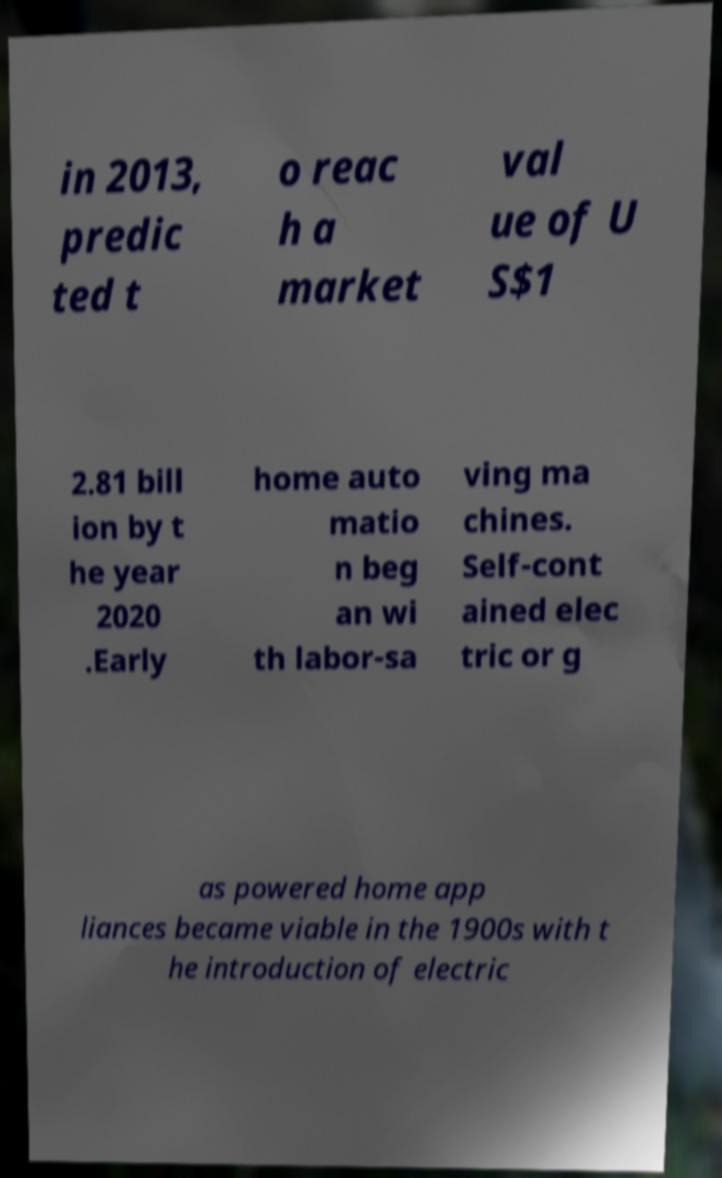What messages or text are displayed in this image? I need them in a readable, typed format. in 2013, predic ted t o reac h a market val ue of U S$1 2.81 bill ion by t he year 2020 .Early home auto matio n beg an wi th labor-sa ving ma chines. Self-cont ained elec tric or g as powered home app liances became viable in the 1900s with t he introduction of electric 